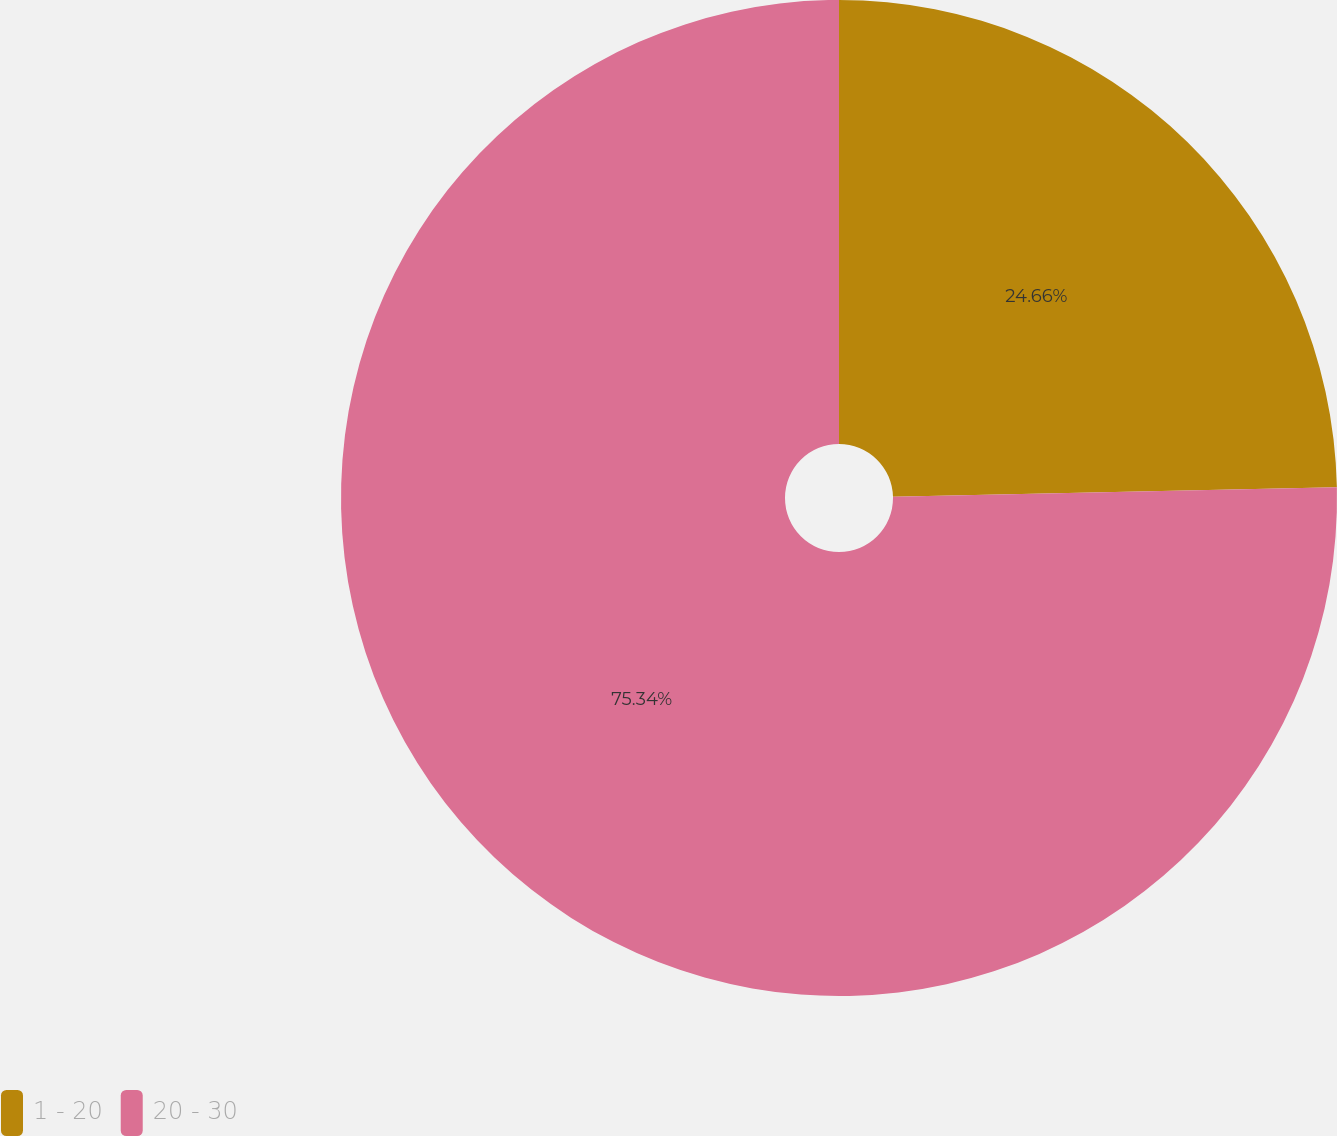Convert chart. <chart><loc_0><loc_0><loc_500><loc_500><pie_chart><fcel>1 - 20<fcel>20 - 30<nl><fcel>24.66%<fcel>75.34%<nl></chart> 